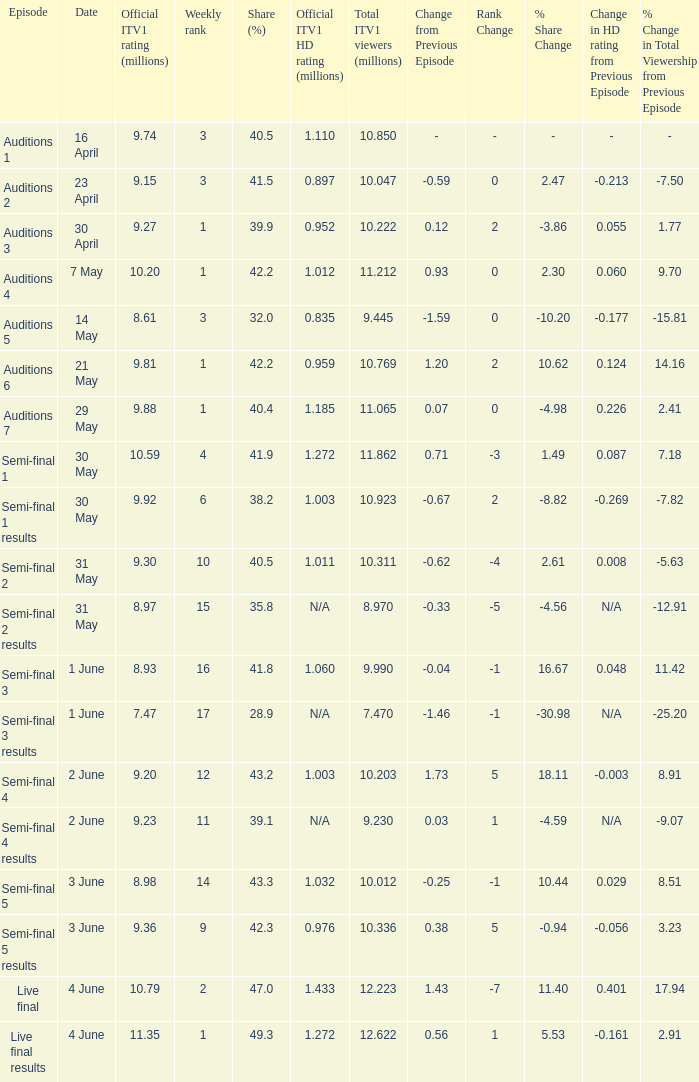What was the total ITV1 viewers in millions for the episode with a share (%) of 28.9?  7.47. 